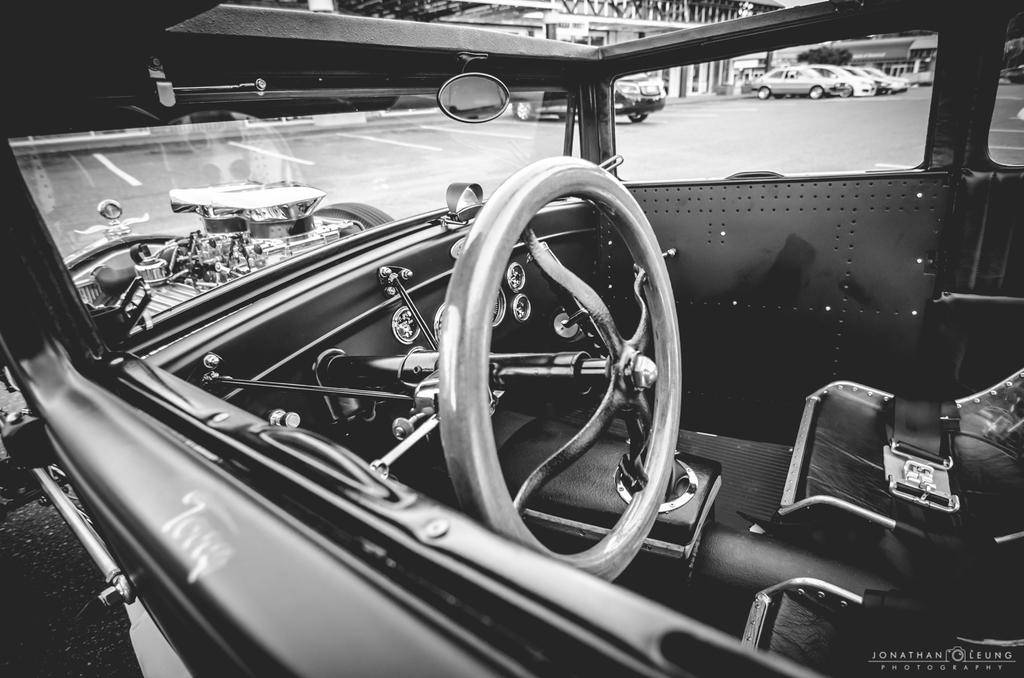What type of vehicle is the main subject of the image? There is a vintage car in the image. What part of the car can be seen in the image? The interior of the car is visible. What is in the background of the image? There is a road in the background of the image. What else can be seen on the road? There are cars parked on the road. What structure is located on the left side of the image? There is visible in the image? What type of trees are planted in the nation square in the image? There is no nation square or trees present in the image; it features a vintage car with a visible interior, a road with parked cars, and a building on the left side. 